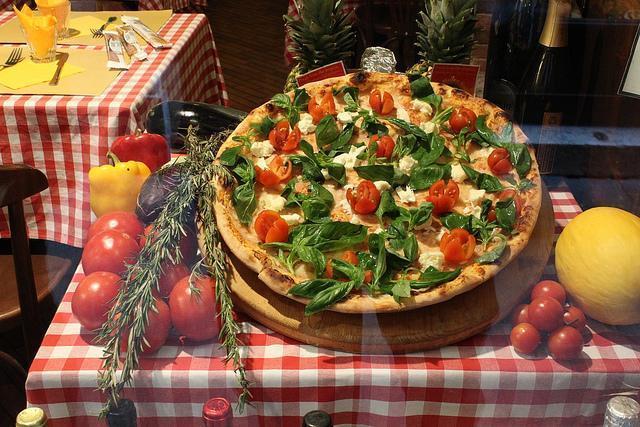Is "The pizza is next to the knife." an appropriate description for the image?
Answer yes or no. No. 